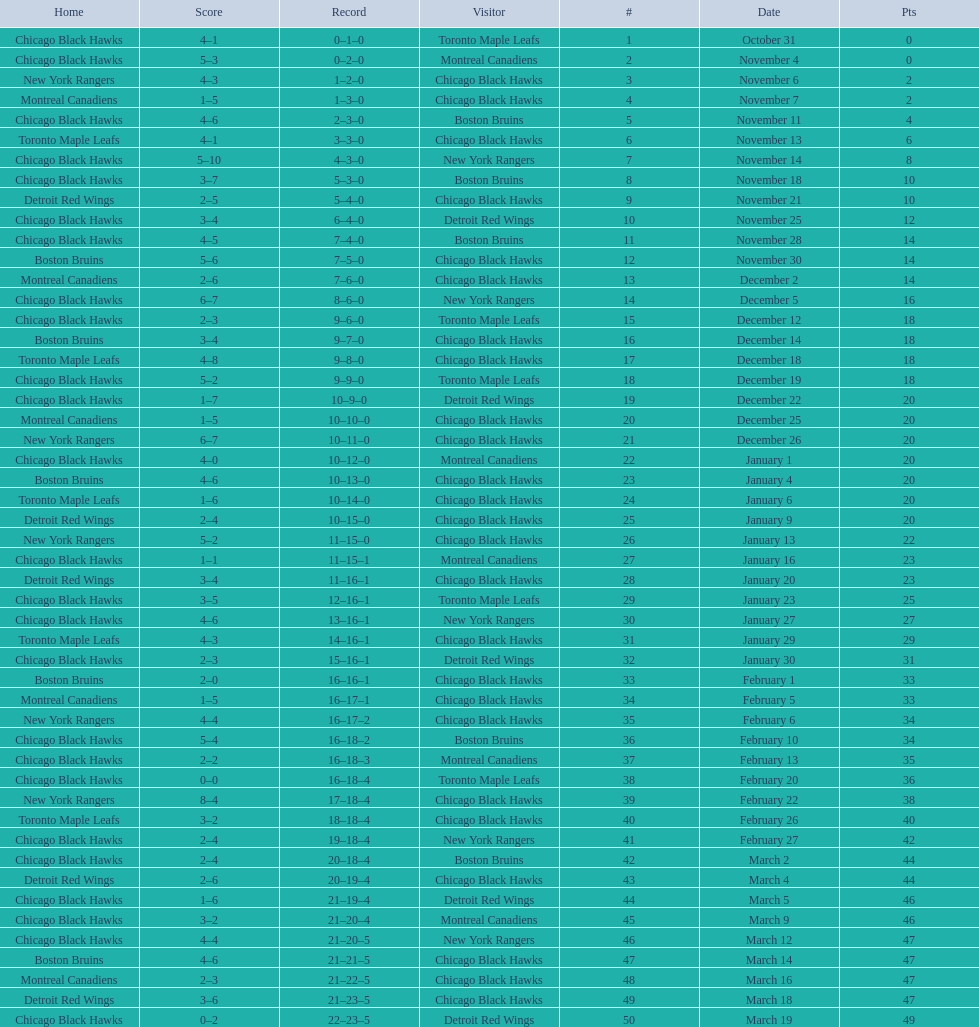Which team was the first one the black hawks lost to? Toronto Maple Leafs. 